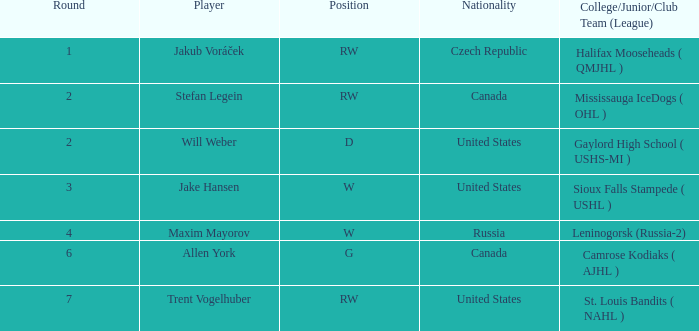What is the nationality of the draft pick playing in the w position from leninogorsk (russia-2)? Russia. 